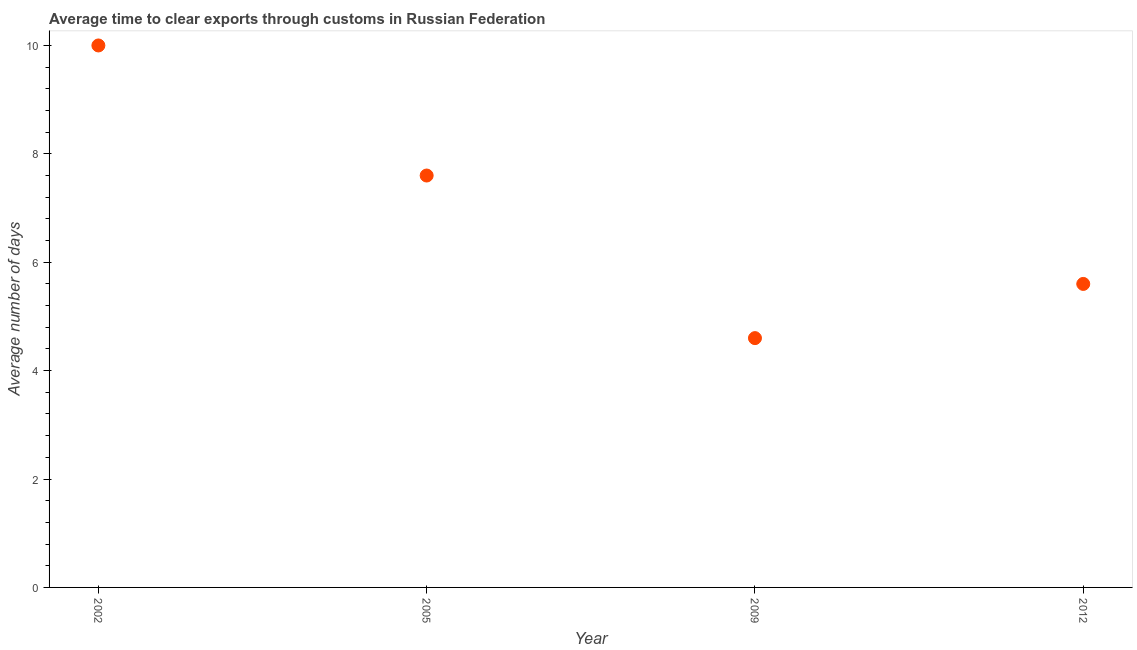What is the time to clear exports through customs in 2012?
Offer a terse response. 5.6. Across all years, what is the minimum time to clear exports through customs?
Provide a short and direct response. 4.6. What is the sum of the time to clear exports through customs?
Your answer should be very brief. 27.8. What is the average time to clear exports through customs per year?
Your response must be concise. 6.95. Do a majority of the years between 2009 and 2002 (inclusive) have time to clear exports through customs greater than 1.2000000000000002 days?
Your answer should be compact. No. What is the ratio of the time to clear exports through customs in 2005 to that in 2009?
Give a very brief answer. 1.65. Is the time to clear exports through customs in 2002 less than that in 2009?
Provide a short and direct response. No. Is the difference between the time to clear exports through customs in 2009 and 2012 greater than the difference between any two years?
Give a very brief answer. No. What is the difference between the highest and the second highest time to clear exports through customs?
Your answer should be compact. 2.4. Is the sum of the time to clear exports through customs in 2002 and 2012 greater than the maximum time to clear exports through customs across all years?
Your answer should be compact. Yes. In how many years, is the time to clear exports through customs greater than the average time to clear exports through customs taken over all years?
Give a very brief answer. 2. How many dotlines are there?
Give a very brief answer. 1. How many years are there in the graph?
Your answer should be compact. 4. Does the graph contain grids?
Your answer should be very brief. No. What is the title of the graph?
Offer a terse response. Average time to clear exports through customs in Russian Federation. What is the label or title of the Y-axis?
Your answer should be compact. Average number of days. What is the Average number of days in 2002?
Your response must be concise. 10. What is the Average number of days in 2009?
Make the answer very short. 4.6. What is the difference between the Average number of days in 2002 and 2005?
Provide a short and direct response. 2.4. What is the difference between the Average number of days in 2009 and 2012?
Give a very brief answer. -1. What is the ratio of the Average number of days in 2002 to that in 2005?
Keep it short and to the point. 1.32. What is the ratio of the Average number of days in 2002 to that in 2009?
Provide a short and direct response. 2.17. What is the ratio of the Average number of days in 2002 to that in 2012?
Make the answer very short. 1.79. What is the ratio of the Average number of days in 2005 to that in 2009?
Provide a succinct answer. 1.65. What is the ratio of the Average number of days in 2005 to that in 2012?
Your answer should be compact. 1.36. What is the ratio of the Average number of days in 2009 to that in 2012?
Your response must be concise. 0.82. 